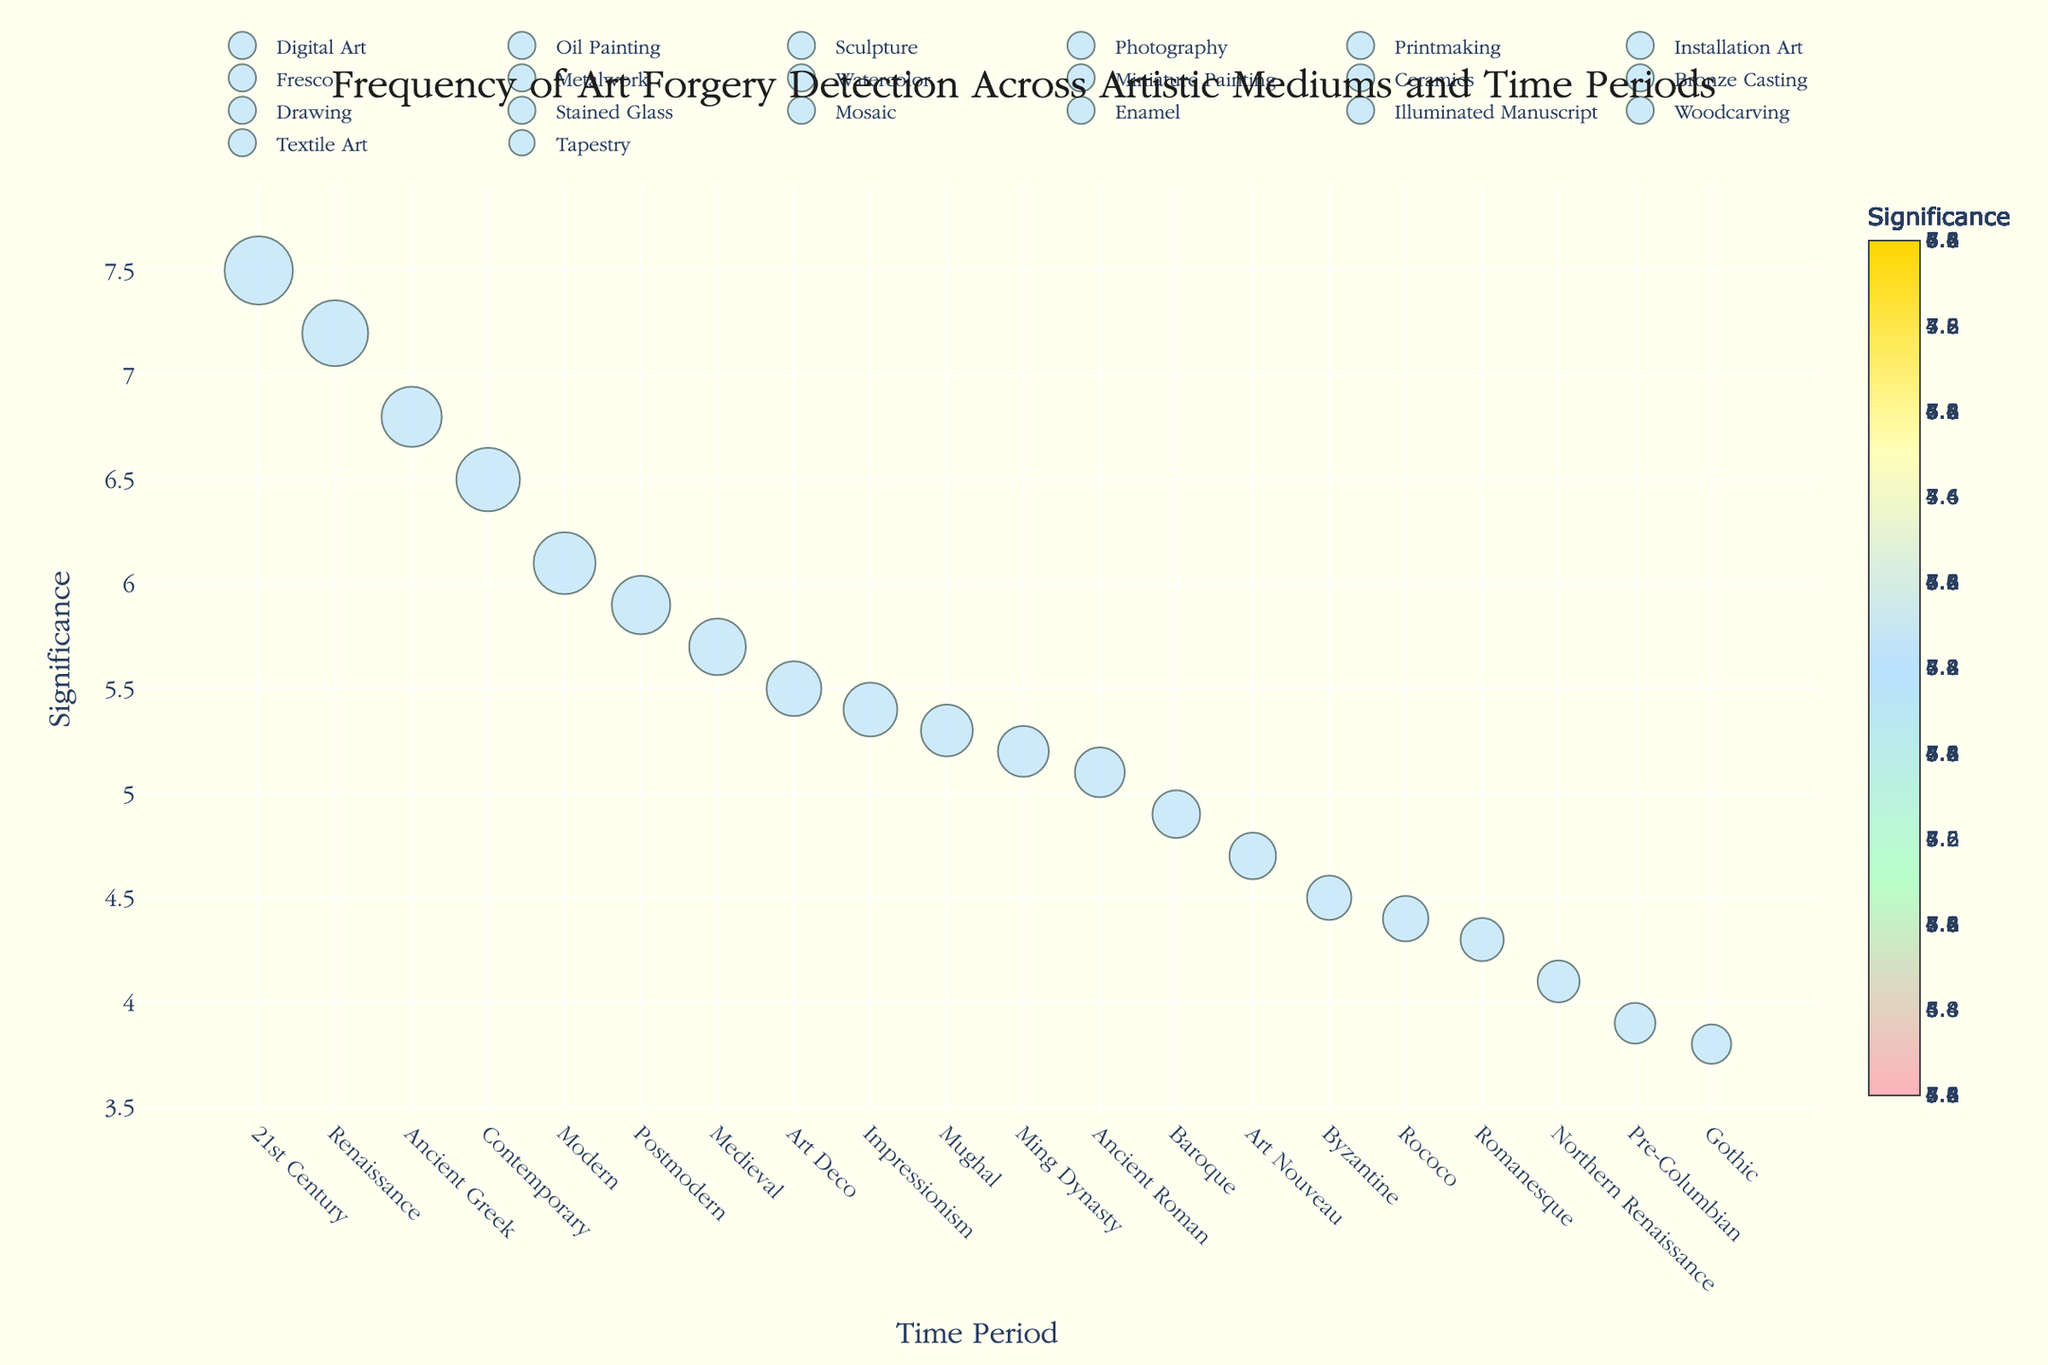What is the title of the figure? The title is typically located at the top of the figure and gives a brief description of what the plot represents.
Answer: Frequency of Art Forgery Detection Across Artistic Mediums and Time Periods Which artistic medium has the highest forgery detection significance? To find which medium has the highest significance, look for the data point plotted the highest on the y-axis.
Answer: Digital Art What is the time period for Watercolor in the Impressionism medium? Locate the Watercolor data point and check the corresponding label on the x-axis.
Answer: Impressionism How does the frequency of forgery for Oil Paintings compare to Photography? Identify the size of the markers for Oil Paintings and Photography in the plot. Larger markers indicate higher frequency.
Answer: Oil Paintings have a lower frequency than Photography Which two mediums from the Modern time period are represented in the plot? Find the markers labeled with the Modern period along the x-axis and note their corresponding mediums.
Answer: Printmaking and Installation Art What is the difference in significance between Enamel and Metalwork? Locate Enamel and Metalwork on the y-axis and subtract their significance values. Enamel has a significance of 4.4, and Metalwork has a significance of 5.5. 5.5 - 4.4.
Answer: 1.1 How many artistic mediums from the Renaissance time period are in the plot? Count the markers labeled with the Renaissance period along the x-axis.
Answer: 1 What is the significance value for the medium with the lowest forgery detection frequency? Locate the smallest marker in the plot and note the significance value on the y-axis. This corresponds to Tapestry, which has a significance value of 3.8.
Answer: 3.8 Which medium from the Baroque period has its forgery detection marked on the plot? Look at the markers labeled with the Baroque period on the x-axis.
Answer: Drawing Can you compare the significance values of Tapestry (Gothic) and Sculpture (Ancient Greek)? Identify the significance values for Tapestry and Sculpture on the y-axis and compare them.
Answer: Sculpture has a higher significance value than Tapestry What is the marker color indicating highest significance in the plot? Identify the color associated with the highest point on the y-axis, where the significance values are marked. Likely it's the final color in the color scale used.
Answer: A shade of bright or golden yellow 